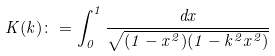<formula> <loc_0><loc_0><loc_500><loc_500>K ( k ) \colon = \int _ { 0 } ^ { 1 } \frac { d x } { \sqrt { ( 1 - x ^ { 2 } ) ( 1 - k ^ { 2 } x ^ { 2 } ) } }</formula> 